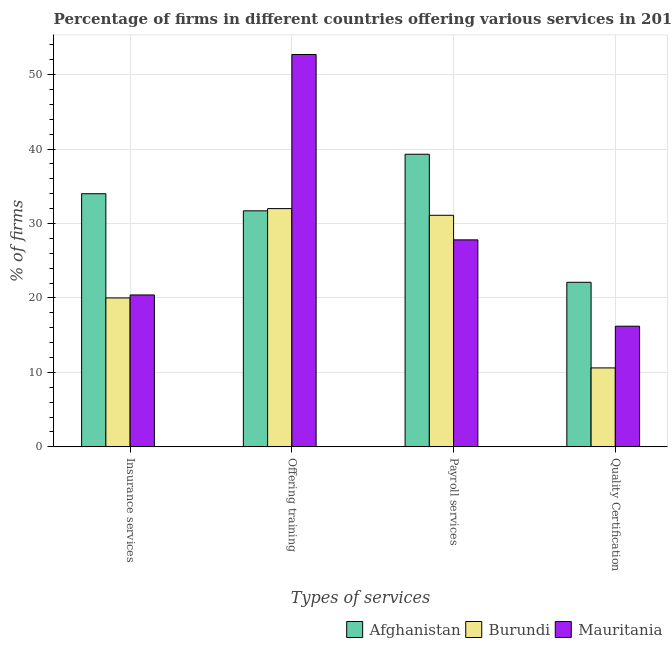How many different coloured bars are there?
Your answer should be very brief. 3. Are the number of bars per tick equal to the number of legend labels?
Offer a very short reply. Yes. How many bars are there on the 1st tick from the right?
Your response must be concise. 3. What is the label of the 2nd group of bars from the left?
Make the answer very short. Offering training. What is the percentage of firms offering training in Mauritania?
Your response must be concise. 52.7. Across all countries, what is the maximum percentage of firms offering insurance services?
Offer a terse response. 34. Across all countries, what is the minimum percentage of firms offering quality certification?
Make the answer very short. 10.6. In which country was the percentage of firms offering payroll services maximum?
Keep it short and to the point. Afghanistan. In which country was the percentage of firms offering payroll services minimum?
Your answer should be compact. Mauritania. What is the total percentage of firms offering insurance services in the graph?
Keep it short and to the point. 74.4. What is the difference between the percentage of firms offering insurance services in Burundi and that in Mauritania?
Your response must be concise. -0.4. What is the difference between the percentage of firms offering training in Burundi and the percentage of firms offering quality certification in Afghanistan?
Provide a succinct answer. 9.9. What is the average percentage of firms offering training per country?
Keep it short and to the point. 38.8. Is the difference between the percentage of firms offering quality certification in Afghanistan and Burundi greater than the difference between the percentage of firms offering payroll services in Afghanistan and Burundi?
Your response must be concise. Yes. What is the difference between the highest and the second highest percentage of firms offering training?
Provide a succinct answer. 20.7. What is the difference between the highest and the lowest percentage of firms offering payroll services?
Offer a terse response. 11.5. Is it the case that in every country, the sum of the percentage of firms offering insurance services and percentage of firms offering training is greater than the sum of percentage of firms offering quality certification and percentage of firms offering payroll services?
Provide a short and direct response. No. What does the 1st bar from the left in Payroll services represents?
Make the answer very short. Afghanistan. What does the 1st bar from the right in Insurance services represents?
Make the answer very short. Mauritania. Is it the case that in every country, the sum of the percentage of firms offering insurance services and percentage of firms offering training is greater than the percentage of firms offering payroll services?
Your answer should be very brief. Yes. How many bars are there?
Keep it short and to the point. 12. How many countries are there in the graph?
Offer a very short reply. 3. What is the difference between two consecutive major ticks on the Y-axis?
Your answer should be very brief. 10. Does the graph contain grids?
Your response must be concise. Yes. What is the title of the graph?
Ensure brevity in your answer.  Percentage of firms in different countries offering various services in 2014. What is the label or title of the X-axis?
Keep it short and to the point. Types of services. What is the label or title of the Y-axis?
Offer a very short reply. % of firms. What is the % of firms in Afghanistan in Insurance services?
Provide a short and direct response. 34. What is the % of firms of Mauritania in Insurance services?
Offer a terse response. 20.4. What is the % of firms of Afghanistan in Offering training?
Give a very brief answer. 31.7. What is the % of firms of Mauritania in Offering training?
Ensure brevity in your answer.  52.7. What is the % of firms in Afghanistan in Payroll services?
Keep it short and to the point. 39.3. What is the % of firms in Burundi in Payroll services?
Your answer should be compact. 31.1. What is the % of firms of Mauritania in Payroll services?
Ensure brevity in your answer.  27.8. What is the % of firms of Afghanistan in Quality Certification?
Offer a very short reply. 22.1. What is the % of firms in Mauritania in Quality Certification?
Give a very brief answer. 16.2. Across all Types of services, what is the maximum % of firms of Afghanistan?
Give a very brief answer. 39.3. Across all Types of services, what is the maximum % of firms in Mauritania?
Your response must be concise. 52.7. Across all Types of services, what is the minimum % of firms of Afghanistan?
Provide a succinct answer. 22.1. Across all Types of services, what is the minimum % of firms of Burundi?
Provide a succinct answer. 10.6. What is the total % of firms in Afghanistan in the graph?
Offer a very short reply. 127.1. What is the total % of firms in Burundi in the graph?
Offer a terse response. 93.7. What is the total % of firms of Mauritania in the graph?
Offer a terse response. 117.1. What is the difference between the % of firms in Afghanistan in Insurance services and that in Offering training?
Ensure brevity in your answer.  2.3. What is the difference between the % of firms in Mauritania in Insurance services and that in Offering training?
Your response must be concise. -32.3. What is the difference between the % of firms of Afghanistan in Insurance services and that in Payroll services?
Make the answer very short. -5.3. What is the difference between the % of firms in Burundi in Insurance services and that in Payroll services?
Provide a short and direct response. -11.1. What is the difference between the % of firms in Mauritania in Insurance services and that in Payroll services?
Ensure brevity in your answer.  -7.4. What is the difference between the % of firms in Burundi in Offering training and that in Payroll services?
Keep it short and to the point. 0.9. What is the difference between the % of firms in Mauritania in Offering training and that in Payroll services?
Your answer should be compact. 24.9. What is the difference between the % of firms in Afghanistan in Offering training and that in Quality Certification?
Provide a short and direct response. 9.6. What is the difference between the % of firms of Burundi in Offering training and that in Quality Certification?
Offer a very short reply. 21.4. What is the difference between the % of firms of Mauritania in Offering training and that in Quality Certification?
Make the answer very short. 36.5. What is the difference between the % of firms of Afghanistan in Payroll services and that in Quality Certification?
Keep it short and to the point. 17.2. What is the difference between the % of firms in Mauritania in Payroll services and that in Quality Certification?
Your response must be concise. 11.6. What is the difference between the % of firms of Afghanistan in Insurance services and the % of firms of Mauritania in Offering training?
Offer a very short reply. -18.7. What is the difference between the % of firms in Burundi in Insurance services and the % of firms in Mauritania in Offering training?
Ensure brevity in your answer.  -32.7. What is the difference between the % of firms of Afghanistan in Insurance services and the % of firms of Burundi in Payroll services?
Your answer should be very brief. 2.9. What is the difference between the % of firms in Afghanistan in Insurance services and the % of firms in Mauritania in Payroll services?
Give a very brief answer. 6.2. What is the difference between the % of firms of Burundi in Insurance services and the % of firms of Mauritania in Payroll services?
Ensure brevity in your answer.  -7.8. What is the difference between the % of firms of Afghanistan in Insurance services and the % of firms of Burundi in Quality Certification?
Your answer should be very brief. 23.4. What is the difference between the % of firms in Afghanistan in Insurance services and the % of firms in Mauritania in Quality Certification?
Provide a succinct answer. 17.8. What is the difference between the % of firms in Burundi in Insurance services and the % of firms in Mauritania in Quality Certification?
Your answer should be compact. 3.8. What is the difference between the % of firms in Afghanistan in Offering training and the % of firms in Burundi in Payroll services?
Your answer should be very brief. 0.6. What is the difference between the % of firms in Afghanistan in Offering training and the % of firms in Mauritania in Payroll services?
Keep it short and to the point. 3.9. What is the difference between the % of firms of Burundi in Offering training and the % of firms of Mauritania in Payroll services?
Give a very brief answer. 4.2. What is the difference between the % of firms in Afghanistan in Offering training and the % of firms in Burundi in Quality Certification?
Provide a short and direct response. 21.1. What is the difference between the % of firms of Afghanistan in Offering training and the % of firms of Mauritania in Quality Certification?
Give a very brief answer. 15.5. What is the difference between the % of firms in Afghanistan in Payroll services and the % of firms in Burundi in Quality Certification?
Your answer should be compact. 28.7. What is the difference between the % of firms in Afghanistan in Payroll services and the % of firms in Mauritania in Quality Certification?
Keep it short and to the point. 23.1. What is the average % of firms of Afghanistan per Types of services?
Your answer should be very brief. 31.77. What is the average % of firms in Burundi per Types of services?
Your answer should be very brief. 23.43. What is the average % of firms in Mauritania per Types of services?
Offer a terse response. 29.27. What is the difference between the % of firms of Afghanistan and % of firms of Burundi in Insurance services?
Make the answer very short. 14. What is the difference between the % of firms of Afghanistan and % of firms of Mauritania in Insurance services?
Ensure brevity in your answer.  13.6. What is the difference between the % of firms of Afghanistan and % of firms of Burundi in Offering training?
Give a very brief answer. -0.3. What is the difference between the % of firms in Afghanistan and % of firms in Mauritania in Offering training?
Offer a terse response. -21. What is the difference between the % of firms of Burundi and % of firms of Mauritania in Offering training?
Provide a short and direct response. -20.7. What is the difference between the % of firms of Afghanistan and % of firms of Burundi in Payroll services?
Provide a short and direct response. 8.2. What is the difference between the % of firms of Afghanistan and % of firms of Burundi in Quality Certification?
Give a very brief answer. 11.5. What is the difference between the % of firms in Burundi and % of firms in Mauritania in Quality Certification?
Ensure brevity in your answer.  -5.6. What is the ratio of the % of firms of Afghanistan in Insurance services to that in Offering training?
Your answer should be very brief. 1.07. What is the ratio of the % of firms of Mauritania in Insurance services to that in Offering training?
Ensure brevity in your answer.  0.39. What is the ratio of the % of firms in Afghanistan in Insurance services to that in Payroll services?
Offer a terse response. 0.87. What is the ratio of the % of firms of Burundi in Insurance services to that in Payroll services?
Offer a very short reply. 0.64. What is the ratio of the % of firms of Mauritania in Insurance services to that in Payroll services?
Offer a terse response. 0.73. What is the ratio of the % of firms of Afghanistan in Insurance services to that in Quality Certification?
Offer a terse response. 1.54. What is the ratio of the % of firms of Burundi in Insurance services to that in Quality Certification?
Provide a succinct answer. 1.89. What is the ratio of the % of firms of Mauritania in Insurance services to that in Quality Certification?
Keep it short and to the point. 1.26. What is the ratio of the % of firms in Afghanistan in Offering training to that in Payroll services?
Provide a short and direct response. 0.81. What is the ratio of the % of firms of Burundi in Offering training to that in Payroll services?
Give a very brief answer. 1.03. What is the ratio of the % of firms in Mauritania in Offering training to that in Payroll services?
Your answer should be very brief. 1.9. What is the ratio of the % of firms of Afghanistan in Offering training to that in Quality Certification?
Offer a terse response. 1.43. What is the ratio of the % of firms of Burundi in Offering training to that in Quality Certification?
Offer a terse response. 3.02. What is the ratio of the % of firms of Mauritania in Offering training to that in Quality Certification?
Provide a succinct answer. 3.25. What is the ratio of the % of firms of Afghanistan in Payroll services to that in Quality Certification?
Offer a terse response. 1.78. What is the ratio of the % of firms in Burundi in Payroll services to that in Quality Certification?
Your answer should be compact. 2.93. What is the ratio of the % of firms of Mauritania in Payroll services to that in Quality Certification?
Your answer should be compact. 1.72. What is the difference between the highest and the second highest % of firms of Afghanistan?
Provide a succinct answer. 5.3. What is the difference between the highest and the second highest % of firms in Burundi?
Your response must be concise. 0.9. What is the difference between the highest and the second highest % of firms in Mauritania?
Your answer should be compact. 24.9. What is the difference between the highest and the lowest % of firms of Afghanistan?
Offer a terse response. 17.2. What is the difference between the highest and the lowest % of firms of Burundi?
Make the answer very short. 21.4. What is the difference between the highest and the lowest % of firms of Mauritania?
Keep it short and to the point. 36.5. 